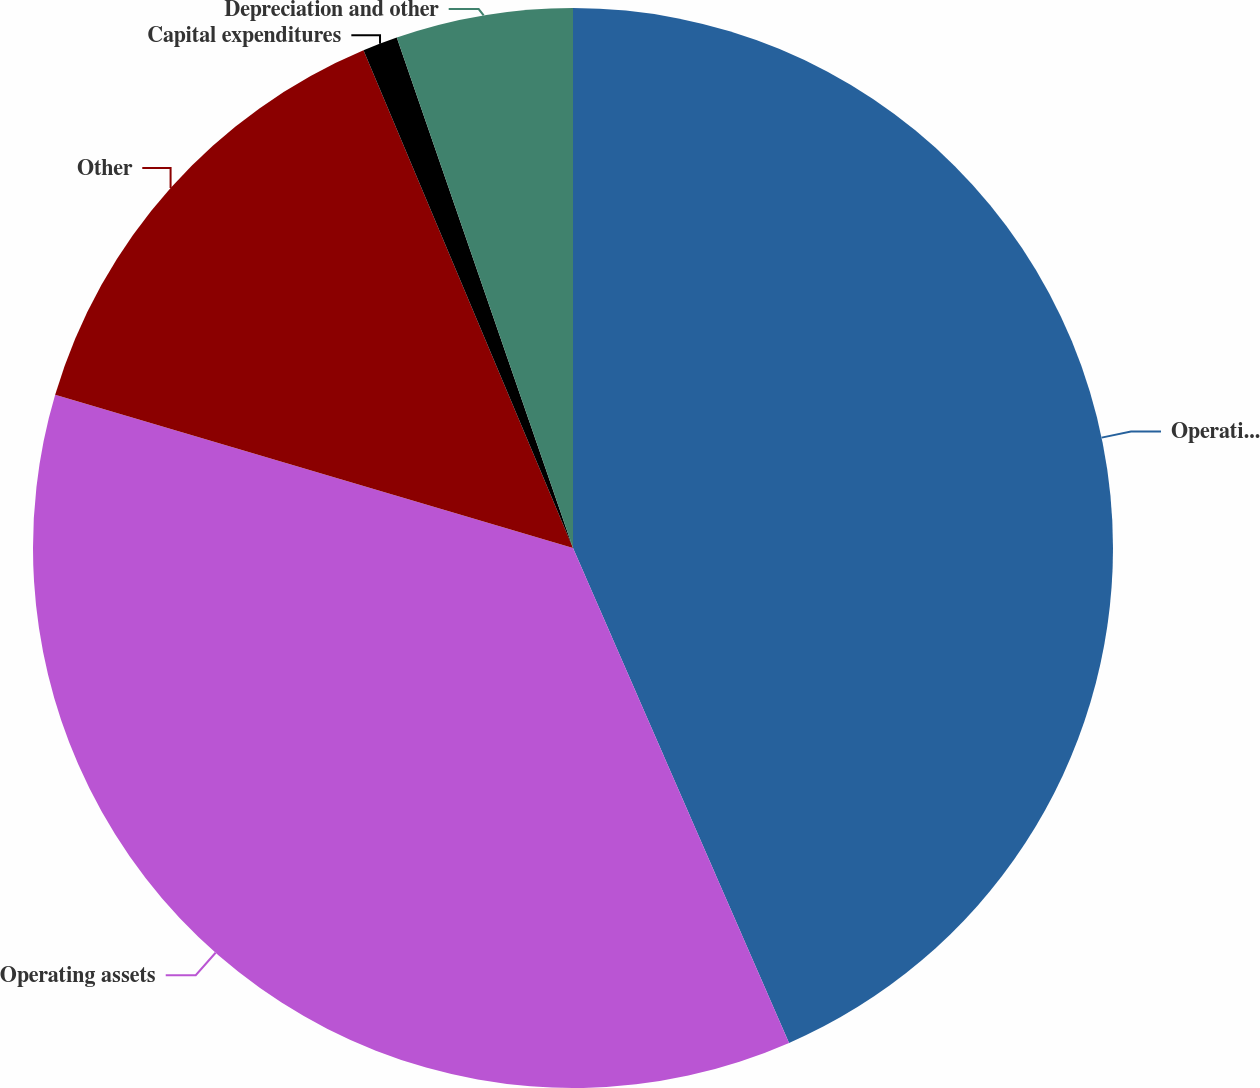<chart> <loc_0><loc_0><loc_500><loc_500><pie_chart><fcel>Operating profit<fcel>Operating assets<fcel>Other<fcel>Capital expenditures<fcel>Depreciation and other<nl><fcel>43.44%<fcel>36.12%<fcel>14.08%<fcel>1.05%<fcel>5.29%<nl></chart> 